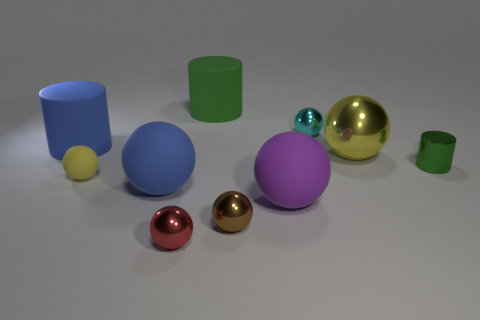Subtract 3 balls. How many balls are left? 4 Subtract all yellow spheres. How many spheres are left? 5 Subtract all red balls. How many balls are left? 6 Subtract all gray balls. Subtract all green cubes. How many balls are left? 7 Subtract all balls. How many objects are left? 3 Add 2 small rubber balls. How many small rubber balls exist? 3 Subtract 0 brown cubes. How many objects are left? 10 Subtract all tiny cylinders. Subtract all big metallic objects. How many objects are left? 8 Add 2 yellow spheres. How many yellow spheres are left? 4 